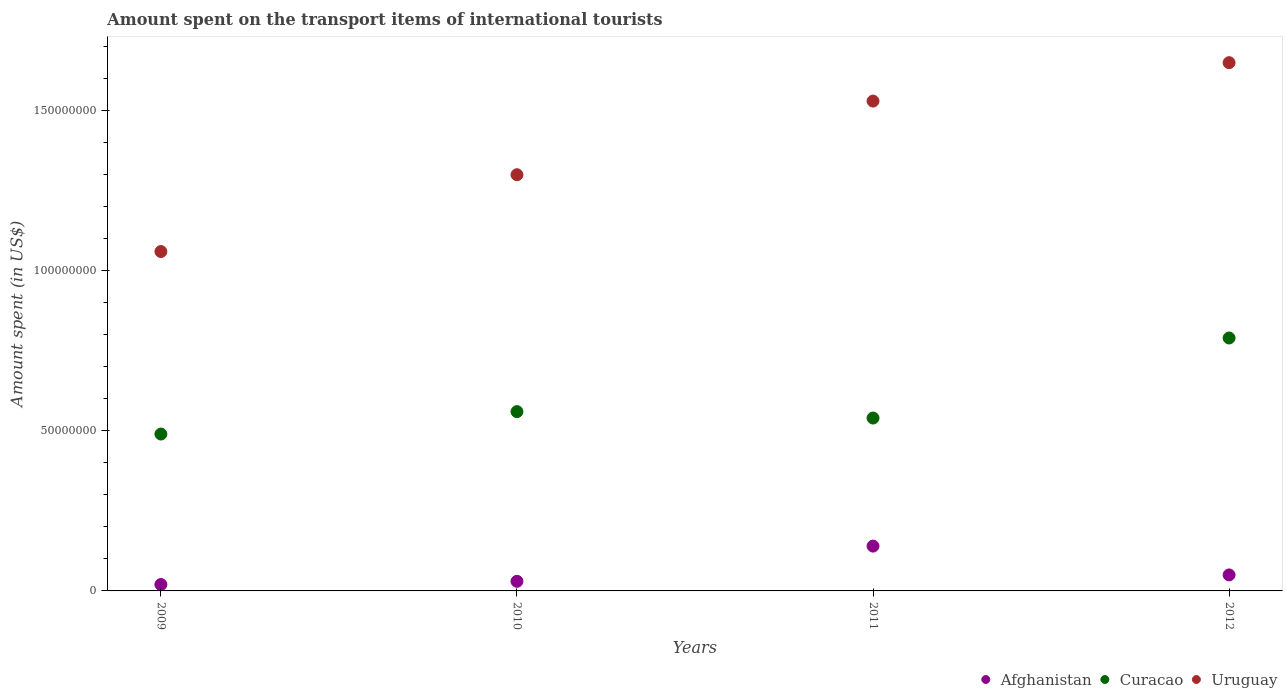What is the amount spent on the transport items of international tourists in Curacao in 2009?
Offer a very short reply. 4.90e+07. Across all years, what is the maximum amount spent on the transport items of international tourists in Afghanistan?
Provide a succinct answer. 1.40e+07. Across all years, what is the minimum amount spent on the transport items of international tourists in Afghanistan?
Make the answer very short. 2.00e+06. What is the total amount spent on the transport items of international tourists in Afghanistan in the graph?
Ensure brevity in your answer.  2.40e+07. What is the difference between the amount spent on the transport items of international tourists in Curacao in 2010 and that in 2012?
Your answer should be very brief. -2.30e+07. What is the difference between the amount spent on the transport items of international tourists in Curacao in 2011 and the amount spent on the transport items of international tourists in Afghanistan in 2010?
Make the answer very short. 5.10e+07. In the year 2009, what is the difference between the amount spent on the transport items of international tourists in Curacao and amount spent on the transport items of international tourists in Uruguay?
Keep it short and to the point. -5.70e+07. In how many years, is the amount spent on the transport items of international tourists in Curacao greater than 50000000 US$?
Your answer should be compact. 3. What is the ratio of the amount spent on the transport items of international tourists in Uruguay in 2009 to that in 2011?
Give a very brief answer. 0.69. Is the amount spent on the transport items of international tourists in Uruguay in 2011 less than that in 2012?
Your answer should be compact. Yes. What is the difference between the highest and the second highest amount spent on the transport items of international tourists in Uruguay?
Your answer should be very brief. 1.20e+07. Is it the case that in every year, the sum of the amount spent on the transport items of international tourists in Uruguay and amount spent on the transport items of international tourists in Afghanistan  is greater than the amount spent on the transport items of international tourists in Curacao?
Give a very brief answer. Yes. Does the amount spent on the transport items of international tourists in Uruguay monotonically increase over the years?
Provide a short and direct response. Yes. How many dotlines are there?
Offer a very short reply. 3. How many years are there in the graph?
Keep it short and to the point. 4. What is the difference between two consecutive major ticks on the Y-axis?
Your response must be concise. 5.00e+07. Are the values on the major ticks of Y-axis written in scientific E-notation?
Your response must be concise. No. Does the graph contain any zero values?
Your answer should be compact. No. What is the title of the graph?
Provide a succinct answer. Amount spent on the transport items of international tourists. Does "San Marino" appear as one of the legend labels in the graph?
Provide a short and direct response. No. What is the label or title of the X-axis?
Offer a very short reply. Years. What is the label or title of the Y-axis?
Provide a succinct answer. Amount spent (in US$). What is the Amount spent (in US$) of Afghanistan in 2009?
Keep it short and to the point. 2.00e+06. What is the Amount spent (in US$) of Curacao in 2009?
Your response must be concise. 4.90e+07. What is the Amount spent (in US$) of Uruguay in 2009?
Offer a terse response. 1.06e+08. What is the Amount spent (in US$) in Afghanistan in 2010?
Provide a succinct answer. 3.00e+06. What is the Amount spent (in US$) in Curacao in 2010?
Offer a very short reply. 5.60e+07. What is the Amount spent (in US$) in Uruguay in 2010?
Provide a short and direct response. 1.30e+08. What is the Amount spent (in US$) in Afghanistan in 2011?
Give a very brief answer. 1.40e+07. What is the Amount spent (in US$) in Curacao in 2011?
Ensure brevity in your answer.  5.40e+07. What is the Amount spent (in US$) in Uruguay in 2011?
Make the answer very short. 1.53e+08. What is the Amount spent (in US$) in Afghanistan in 2012?
Your response must be concise. 5.00e+06. What is the Amount spent (in US$) in Curacao in 2012?
Provide a succinct answer. 7.90e+07. What is the Amount spent (in US$) in Uruguay in 2012?
Provide a succinct answer. 1.65e+08. Across all years, what is the maximum Amount spent (in US$) in Afghanistan?
Your answer should be very brief. 1.40e+07. Across all years, what is the maximum Amount spent (in US$) in Curacao?
Provide a short and direct response. 7.90e+07. Across all years, what is the maximum Amount spent (in US$) in Uruguay?
Your response must be concise. 1.65e+08. Across all years, what is the minimum Amount spent (in US$) in Curacao?
Ensure brevity in your answer.  4.90e+07. Across all years, what is the minimum Amount spent (in US$) of Uruguay?
Ensure brevity in your answer.  1.06e+08. What is the total Amount spent (in US$) in Afghanistan in the graph?
Offer a very short reply. 2.40e+07. What is the total Amount spent (in US$) of Curacao in the graph?
Ensure brevity in your answer.  2.38e+08. What is the total Amount spent (in US$) of Uruguay in the graph?
Your answer should be compact. 5.54e+08. What is the difference between the Amount spent (in US$) in Afghanistan in 2009 and that in 2010?
Provide a short and direct response. -1.00e+06. What is the difference between the Amount spent (in US$) in Curacao in 2009 and that in 2010?
Keep it short and to the point. -7.00e+06. What is the difference between the Amount spent (in US$) in Uruguay in 2009 and that in 2010?
Provide a succinct answer. -2.40e+07. What is the difference between the Amount spent (in US$) in Afghanistan in 2009 and that in 2011?
Keep it short and to the point. -1.20e+07. What is the difference between the Amount spent (in US$) of Curacao in 2009 and that in 2011?
Your answer should be compact. -5.00e+06. What is the difference between the Amount spent (in US$) of Uruguay in 2009 and that in 2011?
Make the answer very short. -4.70e+07. What is the difference between the Amount spent (in US$) of Afghanistan in 2009 and that in 2012?
Provide a short and direct response. -3.00e+06. What is the difference between the Amount spent (in US$) of Curacao in 2009 and that in 2012?
Give a very brief answer. -3.00e+07. What is the difference between the Amount spent (in US$) in Uruguay in 2009 and that in 2012?
Give a very brief answer. -5.90e+07. What is the difference between the Amount spent (in US$) of Afghanistan in 2010 and that in 2011?
Make the answer very short. -1.10e+07. What is the difference between the Amount spent (in US$) in Curacao in 2010 and that in 2011?
Provide a short and direct response. 2.00e+06. What is the difference between the Amount spent (in US$) of Uruguay in 2010 and that in 2011?
Offer a terse response. -2.30e+07. What is the difference between the Amount spent (in US$) in Afghanistan in 2010 and that in 2012?
Offer a terse response. -2.00e+06. What is the difference between the Amount spent (in US$) of Curacao in 2010 and that in 2012?
Give a very brief answer. -2.30e+07. What is the difference between the Amount spent (in US$) of Uruguay in 2010 and that in 2012?
Your answer should be very brief. -3.50e+07. What is the difference between the Amount spent (in US$) in Afghanistan in 2011 and that in 2012?
Give a very brief answer. 9.00e+06. What is the difference between the Amount spent (in US$) of Curacao in 2011 and that in 2012?
Provide a short and direct response. -2.50e+07. What is the difference between the Amount spent (in US$) of Uruguay in 2011 and that in 2012?
Your response must be concise. -1.20e+07. What is the difference between the Amount spent (in US$) in Afghanistan in 2009 and the Amount spent (in US$) in Curacao in 2010?
Provide a succinct answer. -5.40e+07. What is the difference between the Amount spent (in US$) of Afghanistan in 2009 and the Amount spent (in US$) of Uruguay in 2010?
Ensure brevity in your answer.  -1.28e+08. What is the difference between the Amount spent (in US$) in Curacao in 2009 and the Amount spent (in US$) in Uruguay in 2010?
Your response must be concise. -8.10e+07. What is the difference between the Amount spent (in US$) in Afghanistan in 2009 and the Amount spent (in US$) in Curacao in 2011?
Offer a terse response. -5.20e+07. What is the difference between the Amount spent (in US$) in Afghanistan in 2009 and the Amount spent (in US$) in Uruguay in 2011?
Provide a succinct answer. -1.51e+08. What is the difference between the Amount spent (in US$) in Curacao in 2009 and the Amount spent (in US$) in Uruguay in 2011?
Give a very brief answer. -1.04e+08. What is the difference between the Amount spent (in US$) of Afghanistan in 2009 and the Amount spent (in US$) of Curacao in 2012?
Ensure brevity in your answer.  -7.70e+07. What is the difference between the Amount spent (in US$) in Afghanistan in 2009 and the Amount spent (in US$) in Uruguay in 2012?
Give a very brief answer. -1.63e+08. What is the difference between the Amount spent (in US$) of Curacao in 2009 and the Amount spent (in US$) of Uruguay in 2012?
Keep it short and to the point. -1.16e+08. What is the difference between the Amount spent (in US$) in Afghanistan in 2010 and the Amount spent (in US$) in Curacao in 2011?
Your response must be concise. -5.10e+07. What is the difference between the Amount spent (in US$) of Afghanistan in 2010 and the Amount spent (in US$) of Uruguay in 2011?
Make the answer very short. -1.50e+08. What is the difference between the Amount spent (in US$) of Curacao in 2010 and the Amount spent (in US$) of Uruguay in 2011?
Offer a very short reply. -9.70e+07. What is the difference between the Amount spent (in US$) of Afghanistan in 2010 and the Amount spent (in US$) of Curacao in 2012?
Your response must be concise. -7.60e+07. What is the difference between the Amount spent (in US$) in Afghanistan in 2010 and the Amount spent (in US$) in Uruguay in 2012?
Your answer should be compact. -1.62e+08. What is the difference between the Amount spent (in US$) of Curacao in 2010 and the Amount spent (in US$) of Uruguay in 2012?
Ensure brevity in your answer.  -1.09e+08. What is the difference between the Amount spent (in US$) in Afghanistan in 2011 and the Amount spent (in US$) in Curacao in 2012?
Your answer should be very brief. -6.50e+07. What is the difference between the Amount spent (in US$) in Afghanistan in 2011 and the Amount spent (in US$) in Uruguay in 2012?
Your answer should be very brief. -1.51e+08. What is the difference between the Amount spent (in US$) in Curacao in 2011 and the Amount spent (in US$) in Uruguay in 2012?
Your answer should be very brief. -1.11e+08. What is the average Amount spent (in US$) in Curacao per year?
Your answer should be compact. 5.95e+07. What is the average Amount spent (in US$) in Uruguay per year?
Offer a very short reply. 1.38e+08. In the year 2009, what is the difference between the Amount spent (in US$) of Afghanistan and Amount spent (in US$) of Curacao?
Keep it short and to the point. -4.70e+07. In the year 2009, what is the difference between the Amount spent (in US$) of Afghanistan and Amount spent (in US$) of Uruguay?
Ensure brevity in your answer.  -1.04e+08. In the year 2009, what is the difference between the Amount spent (in US$) of Curacao and Amount spent (in US$) of Uruguay?
Give a very brief answer. -5.70e+07. In the year 2010, what is the difference between the Amount spent (in US$) in Afghanistan and Amount spent (in US$) in Curacao?
Offer a very short reply. -5.30e+07. In the year 2010, what is the difference between the Amount spent (in US$) of Afghanistan and Amount spent (in US$) of Uruguay?
Keep it short and to the point. -1.27e+08. In the year 2010, what is the difference between the Amount spent (in US$) in Curacao and Amount spent (in US$) in Uruguay?
Give a very brief answer. -7.40e+07. In the year 2011, what is the difference between the Amount spent (in US$) in Afghanistan and Amount spent (in US$) in Curacao?
Ensure brevity in your answer.  -4.00e+07. In the year 2011, what is the difference between the Amount spent (in US$) in Afghanistan and Amount spent (in US$) in Uruguay?
Give a very brief answer. -1.39e+08. In the year 2011, what is the difference between the Amount spent (in US$) of Curacao and Amount spent (in US$) of Uruguay?
Your answer should be compact. -9.90e+07. In the year 2012, what is the difference between the Amount spent (in US$) of Afghanistan and Amount spent (in US$) of Curacao?
Offer a very short reply. -7.40e+07. In the year 2012, what is the difference between the Amount spent (in US$) of Afghanistan and Amount spent (in US$) of Uruguay?
Provide a succinct answer. -1.60e+08. In the year 2012, what is the difference between the Amount spent (in US$) in Curacao and Amount spent (in US$) in Uruguay?
Provide a short and direct response. -8.60e+07. What is the ratio of the Amount spent (in US$) in Uruguay in 2009 to that in 2010?
Offer a very short reply. 0.82. What is the ratio of the Amount spent (in US$) in Afghanistan in 2009 to that in 2011?
Offer a terse response. 0.14. What is the ratio of the Amount spent (in US$) in Curacao in 2009 to that in 2011?
Offer a very short reply. 0.91. What is the ratio of the Amount spent (in US$) of Uruguay in 2009 to that in 2011?
Your answer should be very brief. 0.69. What is the ratio of the Amount spent (in US$) in Curacao in 2009 to that in 2012?
Provide a short and direct response. 0.62. What is the ratio of the Amount spent (in US$) of Uruguay in 2009 to that in 2012?
Offer a terse response. 0.64. What is the ratio of the Amount spent (in US$) in Afghanistan in 2010 to that in 2011?
Your answer should be very brief. 0.21. What is the ratio of the Amount spent (in US$) in Curacao in 2010 to that in 2011?
Provide a short and direct response. 1.04. What is the ratio of the Amount spent (in US$) of Uruguay in 2010 to that in 2011?
Provide a short and direct response. 0.85. What is the ratio of the Amount spent (in US$) in Curacao in 2010 to that in 2012?
Make the answer very short. 0.71. What is the ratio of the Amount spent (in US$) in Uruguay in 2010 to that in 2012?
Offer a very short reply. 0.79. What is the ratio of the Amount spent (in US$) in Afghanistan in 2011 to that in 2012?
Your answer should be compact. 2.8. What is the ratio of the Amount spent (in US$) in Curacao in 2011 to that in 2012?
Provide a succinct answer. 0.68. What is the ratio of the Amount spent (in US$) in Uruguay in 2011 to that in 2012?
Provide a short and direct response. 0.93. What is the difference between the highest and the second highest Amount spent (in US$) of Afghanistan?
Provide a short and direct response. 9.00e+06. What is the difference between the highest and the second highest Amount spent (in US$) of Curacao?
Make the answer very short. 2.30e+07. What is the difference between the highest and the lowest Amount spent (in US$) of Curacao?
Offer a very short reply. 3.00e+07. What is the difference between the highest and the lowest Amount spent (in US$) in Uruguay?
Keep it short and to the point. 5.90e+07. 